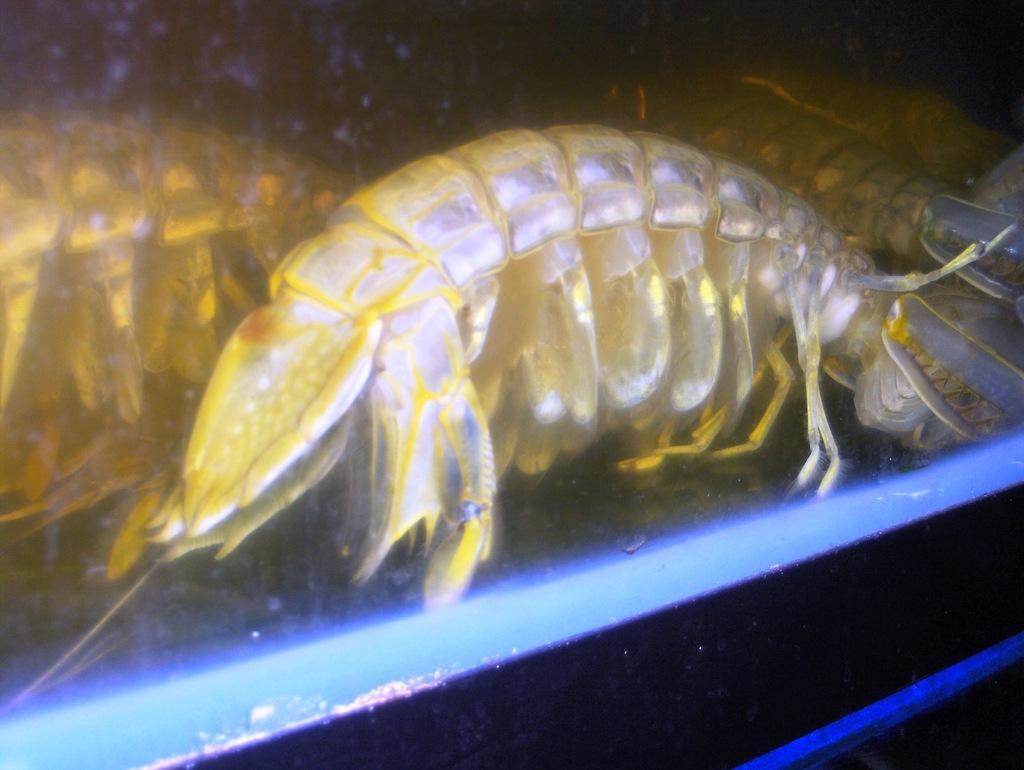How would you summarize this image in a sentence or two? The picture consists of shrimps in a water body. 